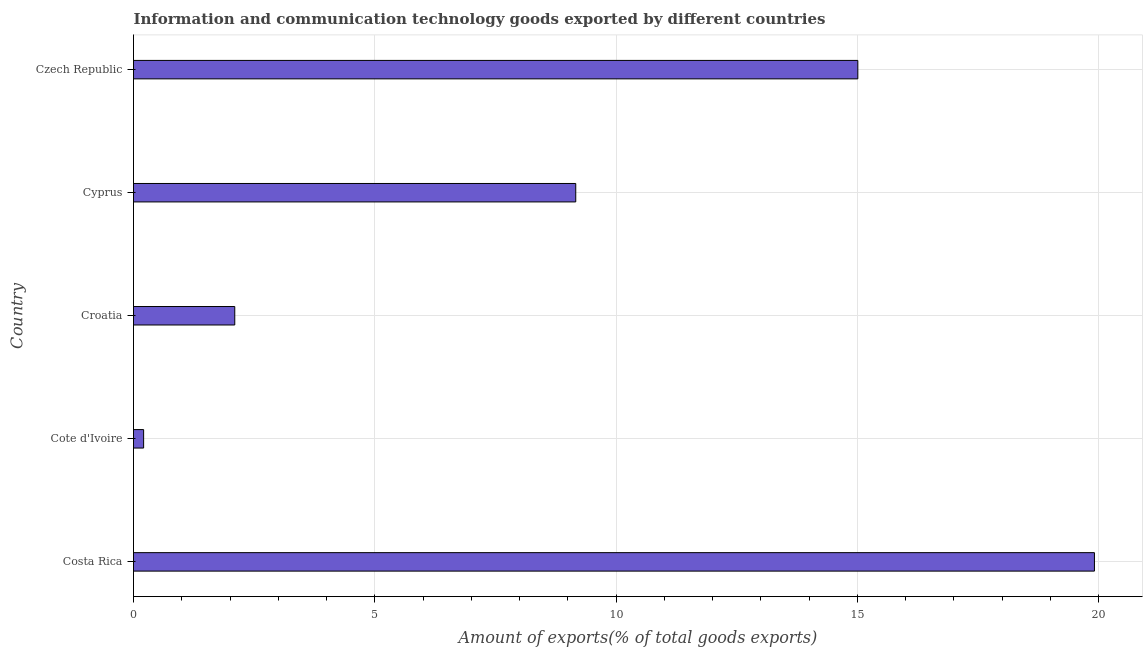What is the title of the graph?
Provide a succinct answer. Information and communication technology goods exported by different countries. What is the label or title of the X-axis?
Keep it short and to the point. Amount of exports(% of total goods exports). What is the amount of ict goods exports in Croatia?
Provide a succinct answer. 2.1. Across all countries, what is the maximum amount of ict goods exports?
Keep it short and to the point. 19.91. Across all countries, what is the minimum amount of ict goods exports?
Keep it short and to the point. 0.21. In which country was the amount of ict goods exports minimum?
Give a very brief answer. Cote d'Ivoire. What is the sum of the amount of ict goods exports?
Offer a very short reply. 46.4. What is the difference between the amount of ict goods exports in Costa Rica and Czech Republic?
Your response must be concise. 4.9. What is the average amount of ict goods exports per country?
Offer a terse response. 9.28. What is the median amount of ict goods exports?
Your response must be concise. 9.17. What is the ratio of the amount of ict goods exports in Cyprus to that in Czech Republic?
Provide a succinct answer. 0.61. Is the amount of ict goods exports in Costa Rica less than that in Cote d'Ivoire?
Keep it short and to the point. No. Is the difference between the amount of ict goods exports in Costa Rica and Croatia greater than the difference between any two countries?
Give a very brief answer. No. What is the difference between the highest and the second highest amount of ict goods exports?
Offer a terse response. 4.9. What is the difference between the highest and the lowest amount of ict goods exports?
Offer a very short reply. 19.7. In how many countries, is the amount of ict goods exports greater than the average amount of ict goods exports taken over all countries?
Offer a terse response. 2. Are all the bars in the graph horizontal?
Keep it short and to the point. Yes. How many countries are there in the graph?
Offer a terse response. 5. Are the values on the major ticks of X-axis written in scientific E-notation?
Keep it short and to the point. No. What is the Amount of exports(% of total goods exports) in Costa Rica?
Provide a succinct answer. 19.91. What is the Amount of exports(% of total goods exports) in Cote d'Ivoire?
Provide a succinct answer. 0.21. What is the Amount of exports(% of total goods exports) of Croatia?
Keep it short and to the point. 2.1. What is the Amount of exports(% of total goods exports) of Cyprus?
Your response must be concise. 9.17. What is the Amount of exports(% of total goods exports) in Czech Republic?
Provide a short and direct response. 15.01. What is the difference between the Amount of exports(% of total goods exports) in Costa Rica and Cote d'Ivoire?
Provide a short and direct response. 19.7. What is the difference between the Amount of exports(% of total goods exports) in Costa Rica and Croatia?
Offer a very short reply. 17.82. What is the difference between the Amount of exports(% of total goods exports) in Costa Rica and Cyprus?
Keep it short and to the point. 10.75. What is the difference between the Amount of exports(% of total goods exports) in Costa Rica and Czech Republic?
Keep it short and to the point. 4.9. What is the difference between the Amount of exports(% of total goods exports) in Cote d'Ivoire and Croatia?
Keep it short and to the point. -1.89. What is the difference between the Amount of exports(% of total goods exports) in Cote d'Ivoire and Cyprus?
Provide a short and direct response. -8.96. What is the difference between the Amount of exports(% of total goods exports) in Cote d'Ivoire and Czech Republic?
Your answer should be very brief. -14.8. What is the difference between the Amount of exports(% of total goods exports) in Croatia and Cyprus?
Your answer should be compact. -7.07. What is the difference between the Amount of exports(% of total goods exports) in Croatia and Czech Republic?
Provide a short and direct response. -12.91. What is the difference between the Amount of exports(% of total goods exports) in Cyprus and Czech Republic?
Make the answer very short. -5.85. What is the ratio of the Amount of exports(% of total goods exports) in Costa Rica to that in Cote d'Ivoire?
Your response must be concise. 94.95. What is the ratio of the Amount of exports(% of total goods exports) in Costa Rica to that in Croatia?
Make the answer very short. 9.49. What is the ratio of the Amount of exports(% of total goods exports) in Costa Rica to that in Cyprus?
Provide a succinct answer. 2.17. What is the ratio of the Amount of exports(% of total goods exports) in Costa Rica to that in Czech Republic?
Your answer should be compact. 1.33. What is the ratio of the Amount of exports(% of total goods exports) in Cote d'Ivoire to that in Croatia?
Your answer should be compact. 0.1. What is the ratio of the Amount of exports(% of total goods exports) in Cote d'Ivoire to that in Cyprus?
Keep it short and to the point. 0.02. What is the ratio of the Amount of exports(% of total goods exports) in Cote d'Ivoire to that in Czech Republic?
Keep it short and to the point. 0.01. What is the ratio of the Amount of exports(% of total goods exports) in Croatia to that in Cyprus?
Keep it short and to the point. 0.23. What is the ratio of the Amount of exports(% of total goods exports) in Croatia to that in Czech Republic?
Your answer should be very brief. 0.14. What is the ratio of the Amount of exports(% of total goods exports) in Cyprus to that in Czech Republic?
Keep it short and to the point. 0.61. 